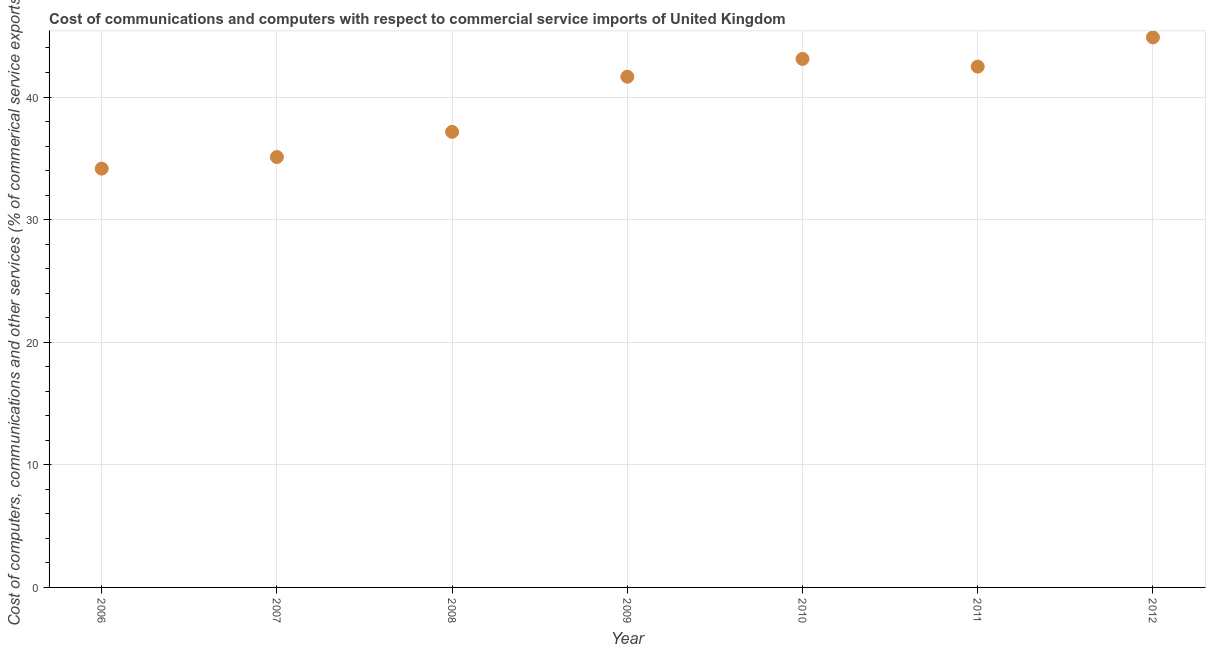What is the cost of communications in 2007?
Keep it short and to the point. 35.1. Across all years, what is the maximum cost of communications?
Make the answer very short. 44.86. Across all years, what is the minimum cost of communications?
Provide a succinct answer. 34.16. In which year was the cost of communications maximum?
Ensure brevity in your answer.  2012. What is the sum of the  computer and other services?
Offer a very short reply. 278.52. What is the difference between the cost of communications in 2008 and 2012?
Offer a terse response. -7.71. What is the average  computer and other services per year?
Provide a short and direct response. 39.79. What is the median  computer and other services?
Keep it short and to the point. 41.65. In how many years, is the  computer and other services greater than 24 %?
Ensure brevity in your answer.  7. What is the ratio of the  computer and other services in 2007 to that in 2011?
Your response must be concise. 0.83. Is the cost of communications in 2006 less than that in 2010?
Ensure brevity in your answer.  Yes. What is the difference between the highest and the second highest  computer and other services?
Provide a short and direct response. 1.76. What is the difference between the highest and the lowest cost of communications?
Give a very brief answer. 10.7. In how many years, is the  computer and other services greater than the average  computer and other services taken over all years?
Offer a very short reply. 4. Does the cost of communications monotonically increase over the years?
Your answer should be compact. No. How many years are there in the graph?
Make the answer very short. 7. What is the difference between two consecutive major ticks on the Y-axis?
Offer a very short reply. 10. Does the graph contain grids?
Provide a short and direct response. Yes. What is the title of the graph?
Offer a terse response. Cost of communications and computers with respect to commercial service imports of United Kingdom. What is the label or title of the Y-axis?
Give a very brief answer. Cost of computers, communications and other services (% of commerical service exports). What is the Cost of computers, communications and other services (% of commerical service exports) in 2006?
Keep it short and to the point. 34.16. What is the Cost of computers, communications and other services (% of commerical service exports) in 2007?
Your answer should be compact. 35.1. What is the Cost of computers, communications and other services (% of commerical service exports) in 2008?
Make the answer very short. 37.16. What is the Cost of computers, communications and other services (% of commerical service exports) in 2009?
Keep it short and to the point. 41.65. What is the Cost of computers, communications and other services (% of commerical service exports) in 2010?
Provide a succinct answer. 43.11. What is the Cost of computers, communications and other services (% of commerical service exports) in 2011?
Ensure brevity in your answer.  42.48. What is the Cost of computers, communications and other services (% of commerical service exports) in 2012?
Ensure brevity in your answer.  44.86. What is the difference between the Cost of computers, communications and other services (% of commerical service exports) in 2006 and 2007?
Your answer should be very brief. -0.95. What is the difference between the Cost of computers, communications and other services (% of commerical service exports) in 2006 and 2008?
Ensure brevity in your answer.  -3. What is the difference between the Cost of computers, communications and other services (% of commerical service exports) in 2006 and 2009?
Your answer should be very brief. -7.5. What is the difference between the Cost of computers, communications and other services (% of commerical service exports) in 2006 and 2010?
Provide a short and direct response. -8.95. What is the difference between the Cost of computers, communications and other services (% of commerical service exports) in 2006 and 2011?
Give a very brief answer. -8.32. What is the difference between the Cost of computers, communications and other services (% of commerical service exports) in 2006 and 2012?
Keep it short and to the point. -10.7. What is the difference between the Cost of computers, communications and other services (% of commerical service exports) in 2007 and 2008?
Your answer should be very brief. -2.05. What is the difference between the Cost of computers, communications and other services (% of commerical service exports) in 2007 and 2009?
Provide a short and direct response. -6.55. What is the difference between the Cost of computers, communications and other services (% of commerical service exports) in 2007 and 2010?
Offer a very short reply. -8. What is the difference between the Cost of computers, communications and other services (% of commerical service exports) in 2007 and 2011?
Give a very brief answer. -7.38. What is the difference between the Cost of computers, communications and other services (% of commerical service exports) in 2007 and 2012?
Your answer should be very brief. -9.76. What is the difference between the Cost of computers, communications and other services (% of commerical service exports) in 2008 and 2009?
Provide a succinct answer. -4.5. What is the difference between the Cost of computers, communications and other services (% of commerical service exports) in 2008 and 2010?
Ensure brevity in your answer.  -5.95. What is the difference between the Cost of computers, communications and other services (% of commerical service exports) in 2008 and 2011?
Provide a succinct answer. -5.32. What is the difference between the Cost of computers, communications and other services (% of commerical service exports) in 2008 and 2012?
Offer a very short reply. -7.71. What is the difference between the Cost of computers, communications and other services (% of commerical service exports) in 2009 and 2010?
Your response must be concise. -1.45. What is the difference between the Cost of computers, communications and other services (% of commerical service exports) in 2009 and 2011?
Offer a very short reply. -0.83. What is the difference between the Cost of computers, communications and other services (% of commerical service exports) in 2009 and 2012?
Give a very brief answer. -3.21. What is the difference between the Cost of computers, communications and other services (% of commerical service exports) in 2010 and 2011?
Your answer should be very brief. 0.63. What is the difference between the Cost of computers, communications and other services (% of commerical service exports) in 2010 and 2012?
Provide a succinct answer. -1.76. What is the difference between the Cost of computers, communications and other services (% of commerical service exports) in 2011 and 2012?
Your response must be concise. -2.38. What is the ratio of the Cost of computers, communications and other services (% of commerical service exports) in 2006 to that in 2007?
Your answer should be compact. 0.97. What is the ratio of the Cost of computers, communications and other services (% of commerical service exports) in 2006 to that in 2008?
Provide a short and direct response. 0.92. What is the ratio of the Cost of computers, communications and other services (% of commerical service exports) in 2006 to that in 2009?
Give a very brief answer. 0.82. What is the ratio of the Cost of computers, communications and other services (% of commerical service exports) in 2006 to that in 2010?
Your response must be concise. 0.79. What is the ratio of the Cost of computers, communications and other services (% of commerical service exports) in 2006 to that in 2011?
Keep it short and to the point. 0.8. What is the ratio of the Cost of computers, communications and other services (% of commerical service exports) in 2006 to that in 2012?
Make the answer very short. 0.76. What is the ratio of the Cost of computers, communications and other services (% of commerical service exports) in 2007 to that in 2008?
Your response must be concise. 0.94. What is the ratio of the Cost of computers, communications and other services (% of commerical service exports) in 2007 to that in 2009?
Keep it short and to the point. 0.84. What is the ratio of the Cost of computers, communications and other services (% of commerical service exports) in 2007 to that in 2010?
Ensure brevity in your answer.  0.81. What is the ratio of the Cost of computers, communications and other services (% of commerical service exports) in 2007 to that in 2011?
Keep it short and to the point. 0.83. What is the ratio of the Cost of computers, communications and other services (% of commerical service exports) in 2007 to that in 2012?
Your answer should be very brief. 0.78. What is the ratio of the Cost of computers, communications and other services (% of commerical service exports) in 2008 to that in 2009?
Offer a very short reply. 0.89. What is the ratio of the Cost of computers, communications and other services (% of commerical service exports) in 2008 to that in 2010?
Your answer should be compact. 0.86. What is the ratio of the Cost of computers, communications and other services (% of commerical service exports) in 2008 to that in 2011?
Offer a terse response. 0.88. What is the ratio of the Cost of computers, communications and other services (% of commerical service exports) in 2008 to that in 2012?
Give a very brief answer. 0.83. What is the ratio of the Cost of computers, communications and other services (% of commerical service exports) in 2009 to that in 2012?
Provide a short and direct response. 0.93. What is the ratio of the Cost of computers, communications and other services (% of commerical service exports) in 2010 to that in 2012?
Offer a very short reply. 0.96. What is the ratio of the Cost of computers, communications and other services (% of commerical service exports) in 2011 to that in 2012?
Your answer should be compact. 0.95. 